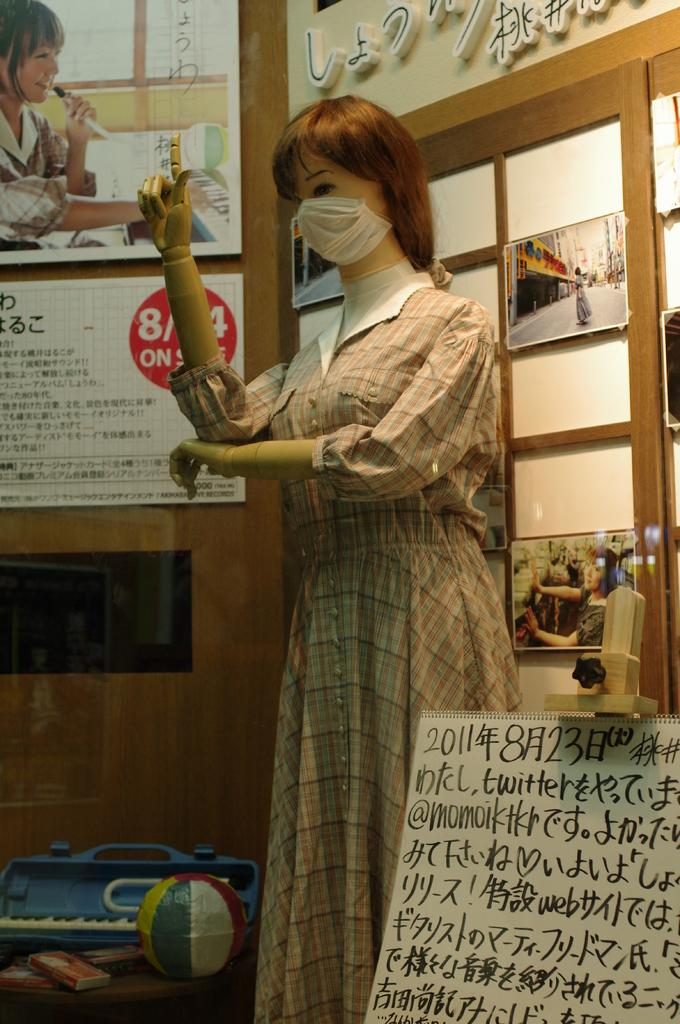What type of decorations are present in the image? There are banners in the image. What architectural feature can be seen in the image? There is a window in the image. What object is used for displaying photos in the image? There is a photo frame in the image. What type of sculpture is visible in the image? There is a statue in the image. What type of surface is present in the image? There is a wall in the image. What type of behavior can be observed in the statue in the image? The statue is an inanimate object and does not exhibit behavior. What unit of measurement is used to describe the size of the banners in the image? The provided facts do not include any information about the size of the banners, so it is impossible to determine the unit of measurement. 